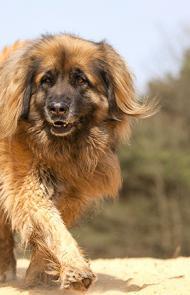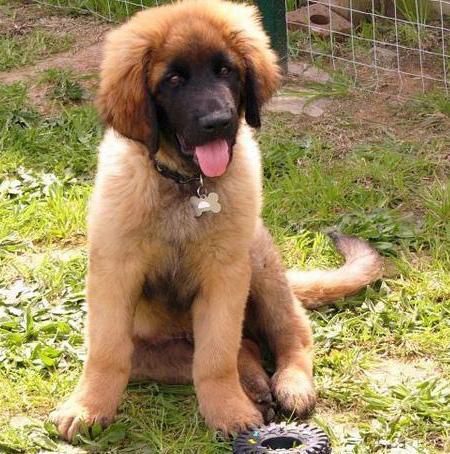The first image is the image on the left, the second image is the image on the right. Analyze the images presented: Is the assertion "There are people touching or petting a big dog with a black nose." valid? Answer yes or no. No. The first image is the image on the left, the second image is the image on the right. Examine the images to the left and right. Is the description "A human is standing next to a large dog." accurate? Answer yes or no. No. 